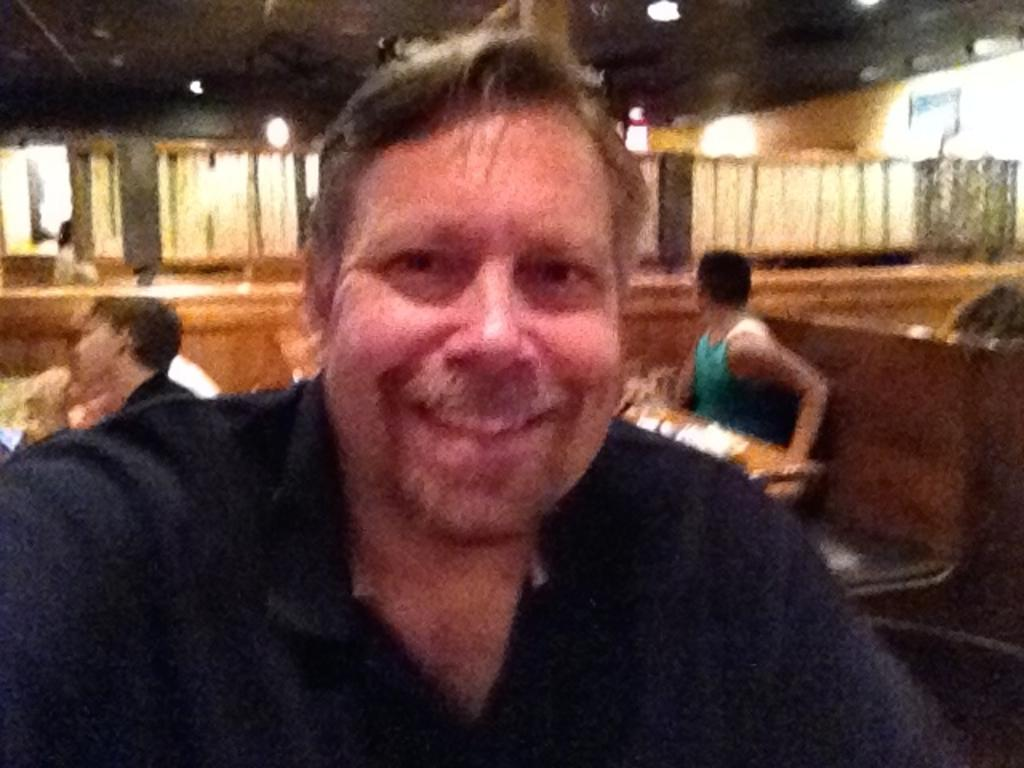What is the expression on the man's face in the image? The man is smiling in the image. How many people are sitting on the bench in the image? There are two people sitting on the bench in the image. What piece of furniture is present in the image besides the bench? There is a table in the image. What type of location might the image depict? The setting appears to be a restaurant. What type of spark can be seen between the two people sitting on the bench? There is no spark visible between the two people sitting on the bench in the image. 